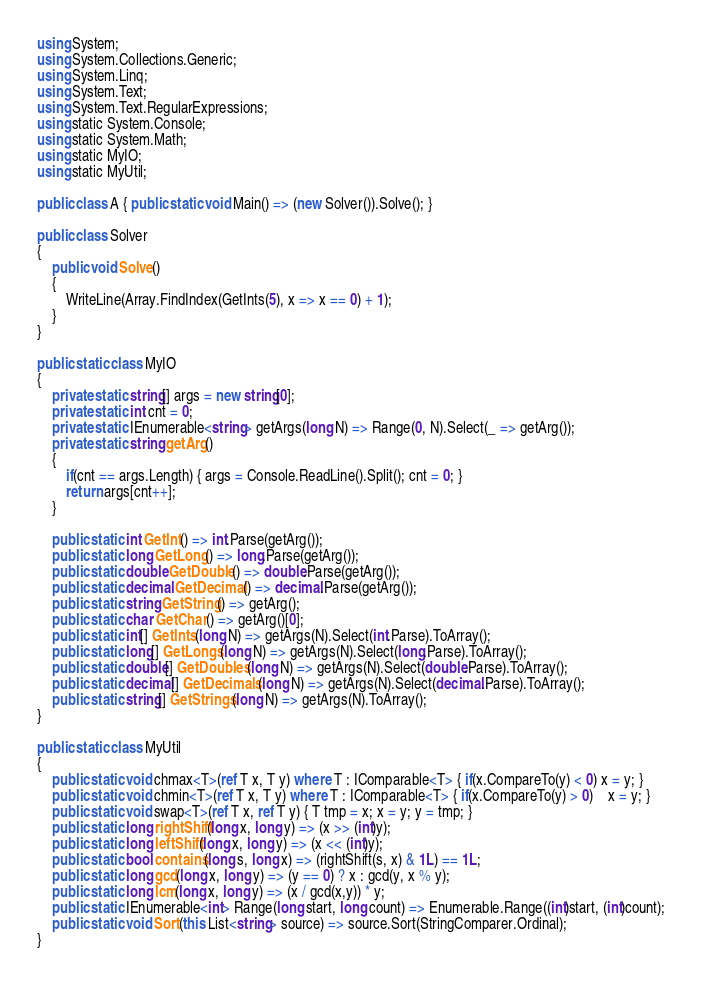Convert code to text. <code><loc_0><loc_0><loc_500><loc_500><_C#_>using System;
using System.Collections.Generic;
using System.Linq;
using System.Text;
using System.Text.RegularExpressions;
using static System.Console;
using static System.Math;
using static MyIO;
using static MyUtil;

public class A { public static void Main() => (new Solver()).Solve(); }

public class Solver
{
	public void Solve()
	{
		WriteLine(Array.FindIndex(GetInts(5), x => x == 0) + 1);
	}
}

public static class MyIO
{
	private static string[] args = new string[0];
	private static int cnt = 0;
	private static IEnumerable<string> getArgs(long N) => Range(0, N).Select(_ => getArg());
	private static string getArg()
	{
		if(cnt == args.Length) { args = Console.ReadLine().Split(); cnt = 0; }
		return args[cnt++];
	}

	public static int GetInt() => int.Parse(getArg());
	public static long GetLong() => long.Parse(getArg());
	public static double GetDouble() => double.Parse(getArg());
	public static decimal GetDecimal() => decimal.Parse(getArg());
	public static string GetString() => getArg();
	public static char GetChar() => getArg()[0];
	public static int[] GetInts(long N) => getArgs(N).Select(int.Parse).ToArray();
	public static long[] GetLongs(long N) => getArgs(N).Select(long.Parse).ToArray();
	public static double[] GetDoubles(long N) => getArgs(N).Select(double.Parse).ToArray();
	public static decimal[] GetDecimals(long N) => getArgs(N).Select(decimal.Parse).ToArray();
	public static string[] GetStrings(long N) => getArgs(N).ToArray();
}

public static class MyUtil
{
	public static void chmax<T>(ref T x, T y) where T : IComparable<T> { if(x.CompareTo(y) < 0) x = y; }
	public static void chmin<T>(ref T x, T y) where T : IComparable<T> { if(x.CompareTo(y) > 0)	x = y; }
	public static void swap<T>(ref T x, ref T y) { T tmp = x; x = y; y = tmp; }
	public static long rightShift(long x, long y) => (x >> (int)y);
	public static long leftShift(long x, long y) => (x << (int)y);
	public static bool contains(long s, long x) => (rightShift(s, x) & 1L) == 1L;
	public static long gcd(long x, long y) => (y == 0) ? x : gcd(y, x % y);
	public static long lcm(long x, long y) => (x / gcd(x,y)) * y;	
	public static IEnumerable<int> Range(long start, long count) => Enumerable.Range((int)start, (int)count);
	public static void Sort(this List<string> source) => source.Sort(StringComparer.Ordinal);
}
</code> 